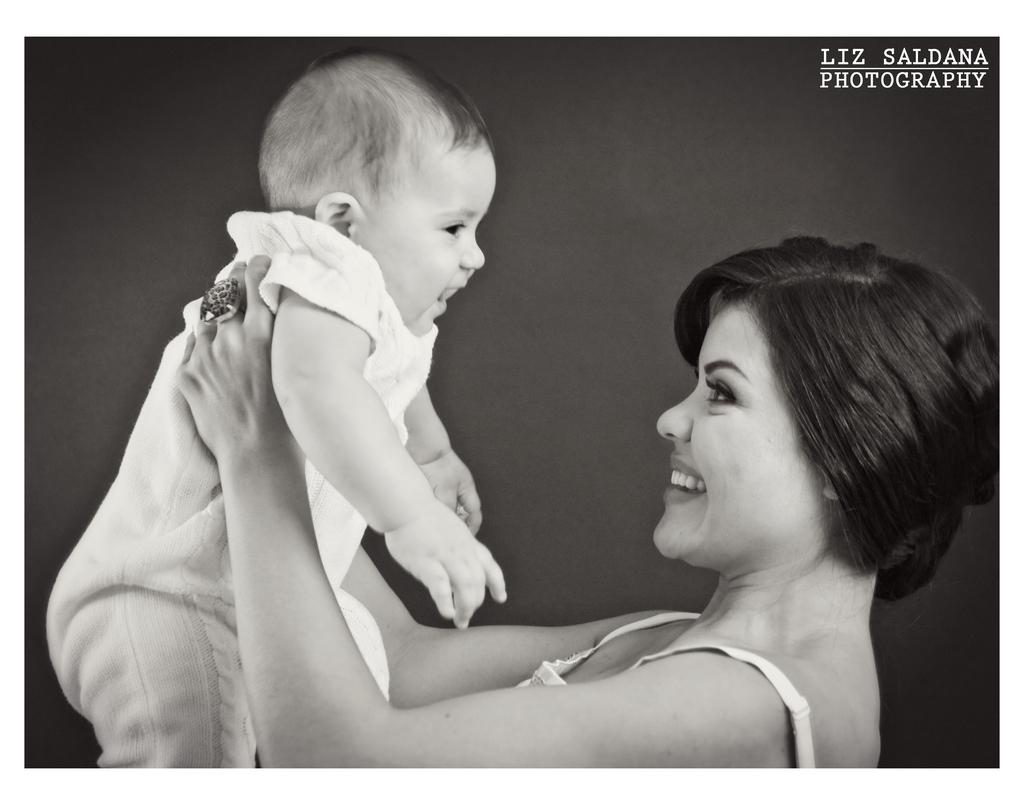Who is the main subject in the image? There is a mother in the image. What is the mother doing in the image? The mother is holding a small baby. What is the mother's expression in the image? The mother is smiling. What can be seen behind the mother and baby in the image? There is a grey background in the image. How many oranges are on the table in the image? There are no oranges present in the image. What type of paper is being used by the mother in the image? There is no paper visible in the image. 